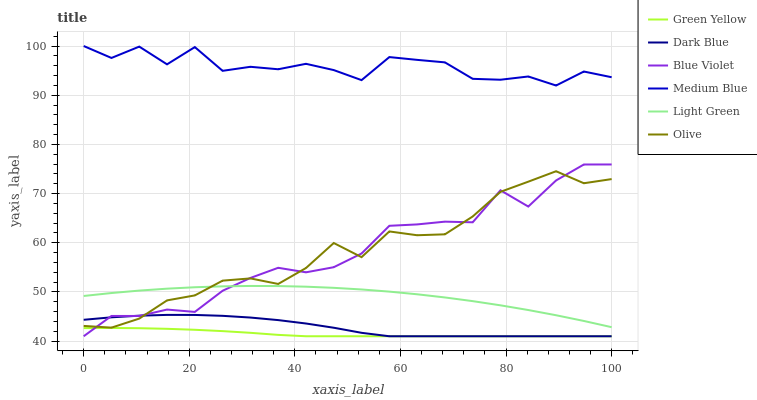Does Green Yellow have the minimum area under the curve?
Answer yes or no. Yes. Does Medium Blue have the maximum area under the curve?
Answer yes or no. Yes. Does Dark Blue have the minimum area under the curve?
Answer yes or no. No. Does Dark Blue have the maximum area under the curve?
Answer yes or no. No. Is Green Yellow the smoothest?
Answer yes or no. Yes. Is Medium Blue the roughest?
Answer yes or no. Yes. Is Dark Blue the smoothest?
Answer yes or no. No. Is Dark Blue the roughest?
Answer yes or no. No. Does Dark Blue have the lowest value?
Answer yes or no. Yes. Does Light Green have the lowest value?
Answer yes or no. No. Does Medium Blue have the highest value?
Answer yes or no. Yes. Does Dark Blue have the highest value?
Answer yes or no. No. Is Light Green less than Medium Blue?
Answer yes or no. Yes. Is Olive greater than Green Yellow?
Answer yes or no. Yes. Does Green Yellow intersect Dark Blue?
Answer yes or no. Yes. Is Green Yellow less than Dark Blue?
Answer yes or no. No. Is Green Yellow greater than Dark Blue?
Answer yes or no. No. Does Light Green intersect Medium Blue?
Answer yes or no. No. 